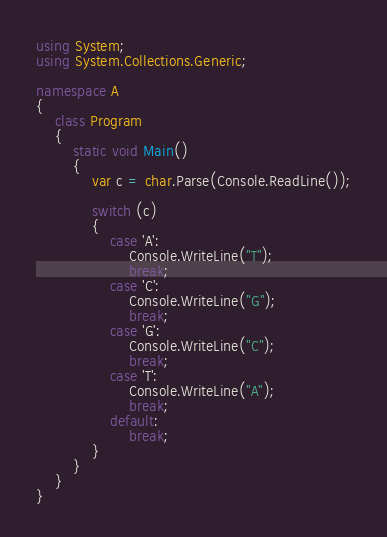<code> <loc_0><loc_0><loc_500><loc_500><_C#_>
using System;
using System.Collections.Generic;

namespace A
{
	class Program
	{
		static void Main()
		{
			var c = char.Parse(Console.ReadLine());

			switch (c)
			{
				case 'A':
					Console.WriteLine("T");
					break;
				case 'C':
					Console.WriteLine("G");
					break;
				case 'G':
					Console.WriteLine("C");
					break;
				case 'T':
					Console.WriteLine("A");
					break;
				default:
					break;
			}
		}
	}
}
</code> 